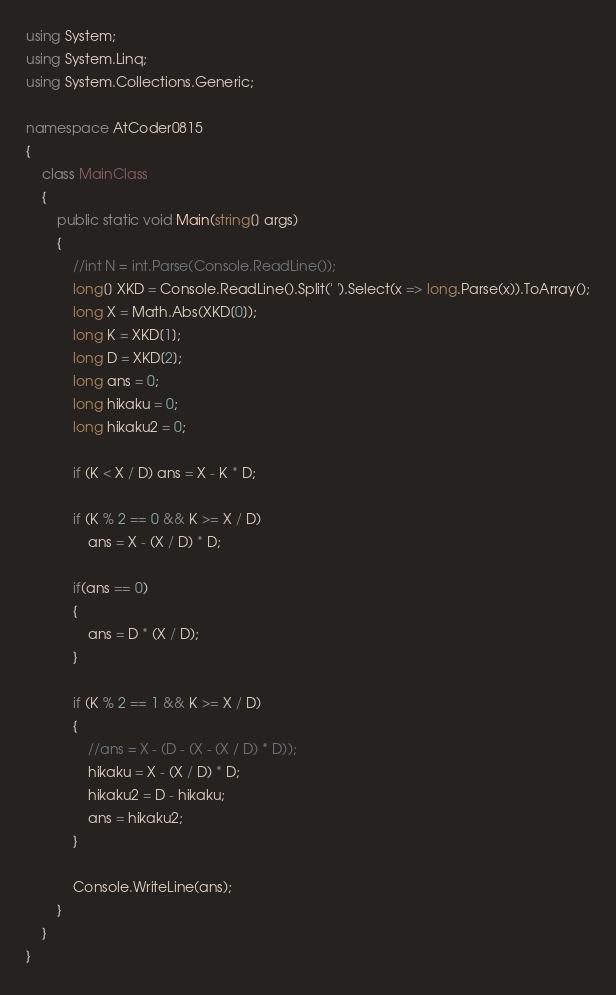<code> <loc_0><loc_0><loc_500><loc_500><_C#_>using System;
using System.Linq;
using System.Collections.Generic;

namespace AtCoder0815
{
    class MainClass
    {
        public static void Main(string[] args)
        {
            //int N = int.Parse(Console.ReadLine());
            long[] XKD = Console.ReadLine().Split(' ').Select(x => long.Parse(x)).ToArray();
            long X = Math.Abs(XKD[0]);
            long K = XKD[1];
            long D = XKD[2];
            long ans = 0;
            long hikaku = 0;
            long hikaku2 = 0;

            if (K < X / D) ans = X - K * D;

            if (K % 2 == 0 && K >= X / D)
                ans = X - (X / D) * D;

            if(ans == 0)
            {
                ans = D * (X / D);
            }

            if (K % 2 == 1 && K >= X / D)
            {
                //ans = X - (D - (X - (X / D) * D));
                hikaku = X - (X / D) * D;
                hikaku2 = D - hikaku;
                ans = hikaku2;
            }

            Console.WriteLine(ans);
        }
    }
}
</code> 